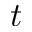Convert formula to latex. <formula><loc_0><loc_0><loc_500><loc_500>t</formula> 